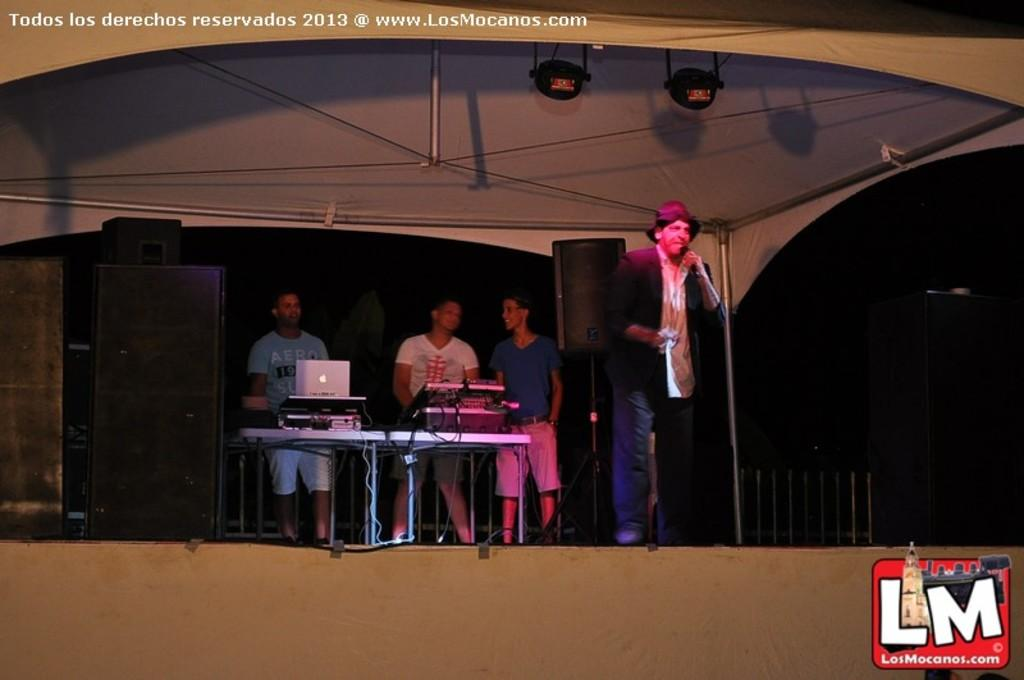How many people are on stage in the image? There are four men standing on stage in the image. What can be seen in the image that is used for amplifying sound? There are speakers in the image. What electronic device is visible in the image? There is a laptop in the image. What type of furniture is present in the image? There are tables in the image. How would you describe the lighting in the image? The background is dark in the image. What type of locket is hanging from the laptop in the image? There is no locket present in the image, and the laptop is not hanging from anything. 